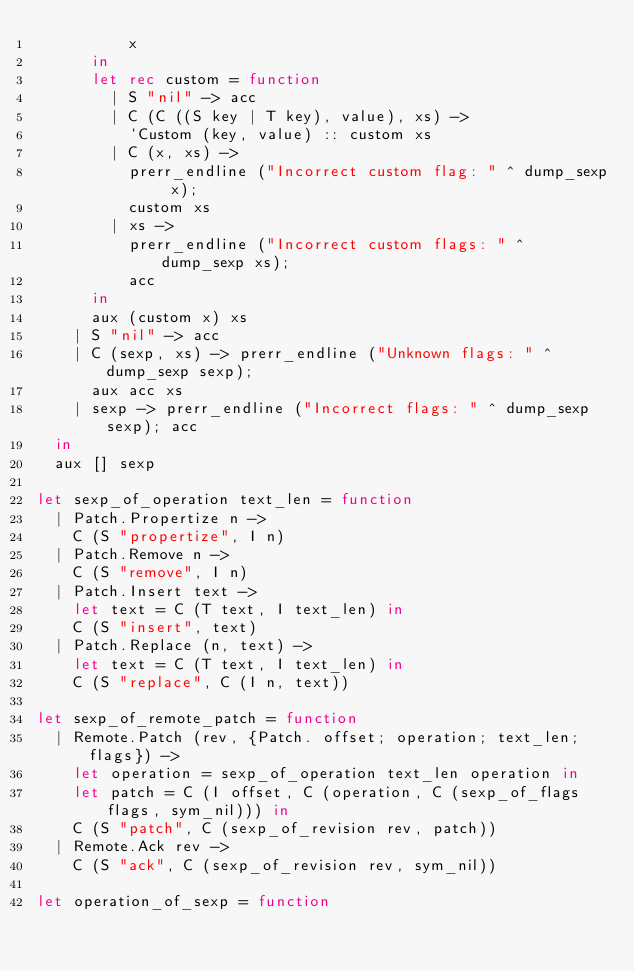Convert code to text. <code><loc_0><loc_0><loc_500><loc_500><_OCaml_>          x
      in
      let rec custom = function
        | S "nil" -> acc
        | C (C ((S key | T key), value), xs) ->
          `Custom (key, value) :: custom xs
        | C (x, xs) ->
          prerr_endline ("Incorrect custom flag: " ^ dump_sexp x);
          custom xs
        | xs ->
          prerr_endline ("Incorrect custom flags: " ^ dump_sexp xs);
          acc
      in
      aux (custom x) xs
    | S "nil" -> acc
    | C (sexp, xs) -> prerr_endline ("Unknown flags: " ^ dump_sexp sexp);
      aux acc xs
    | sexp -> prerr_endline ("Incorrect flags: " ^ dump_sexp sexp); acc
  in
  aux [] sexp

let sexp_of_operation text_len = function
  | Patch.Propertize n ->
    C (S "propertize", I n)
  | Patch.Remove n ->
    C (S "remove", I n)
  | Patch.Insert text ->
    let text = C (T text, I text_len) in
    C (S "insert", text)
  | Patch.Replace (n, text) ->
    let text = C (T text, I text_len) in
    C (S "replace", C (I n, text))

let sexp_of_remote_patch = function
  | Remote.Patch (rev, {Patch. offset; operation; text_len; flags}) ->
    let operation = sexp_of_operation text_len operation in
    let patch = C (I offset, C (operation, C (sexp_of_flags flags, sym_nil))) in
    C (S "patch", C (sexp_of_revision rev, patch))
  | Remote.Ack rev ->
    C (S "ack", C (sexp_of_revision rev, sym_nil))

let operation_of_sexp = function</code> 